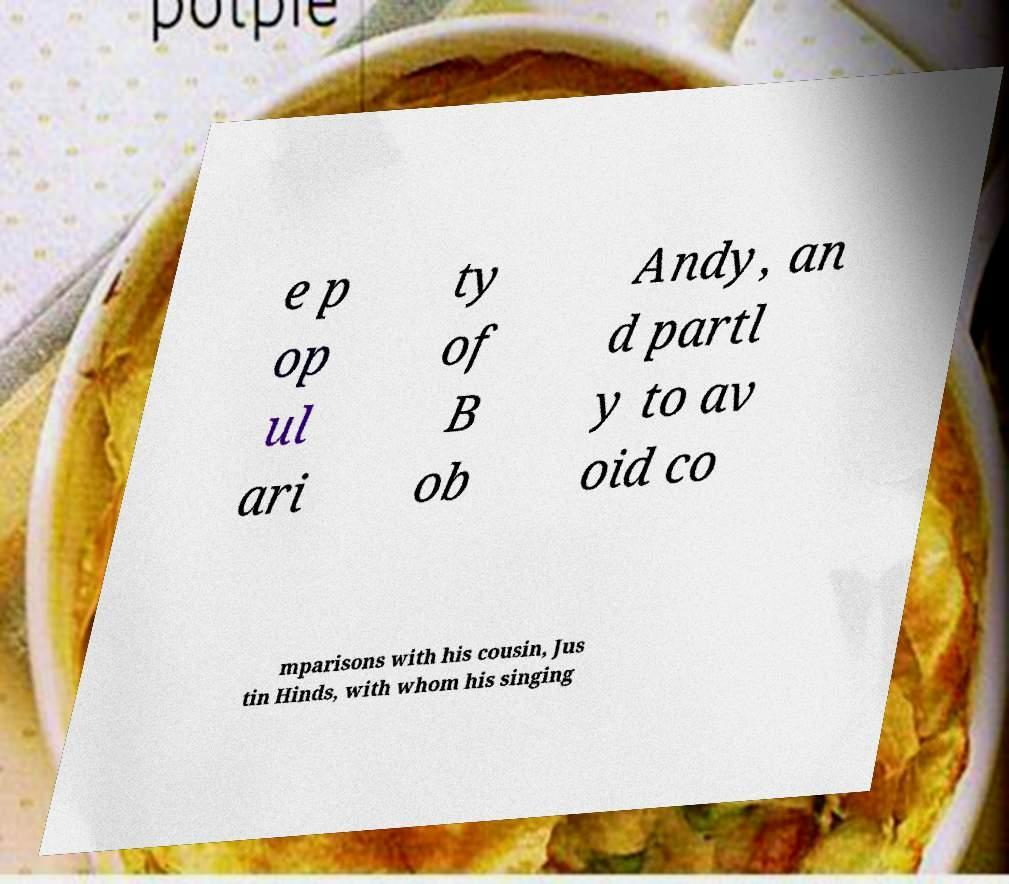For documentation purposes, I need the text within this image transcribed. Could you provide that? e p op ul ari ty of B ob Andy, an d partl y to av oid co mparisons with his cousin, Jus tin Hinds, with whom his singing 